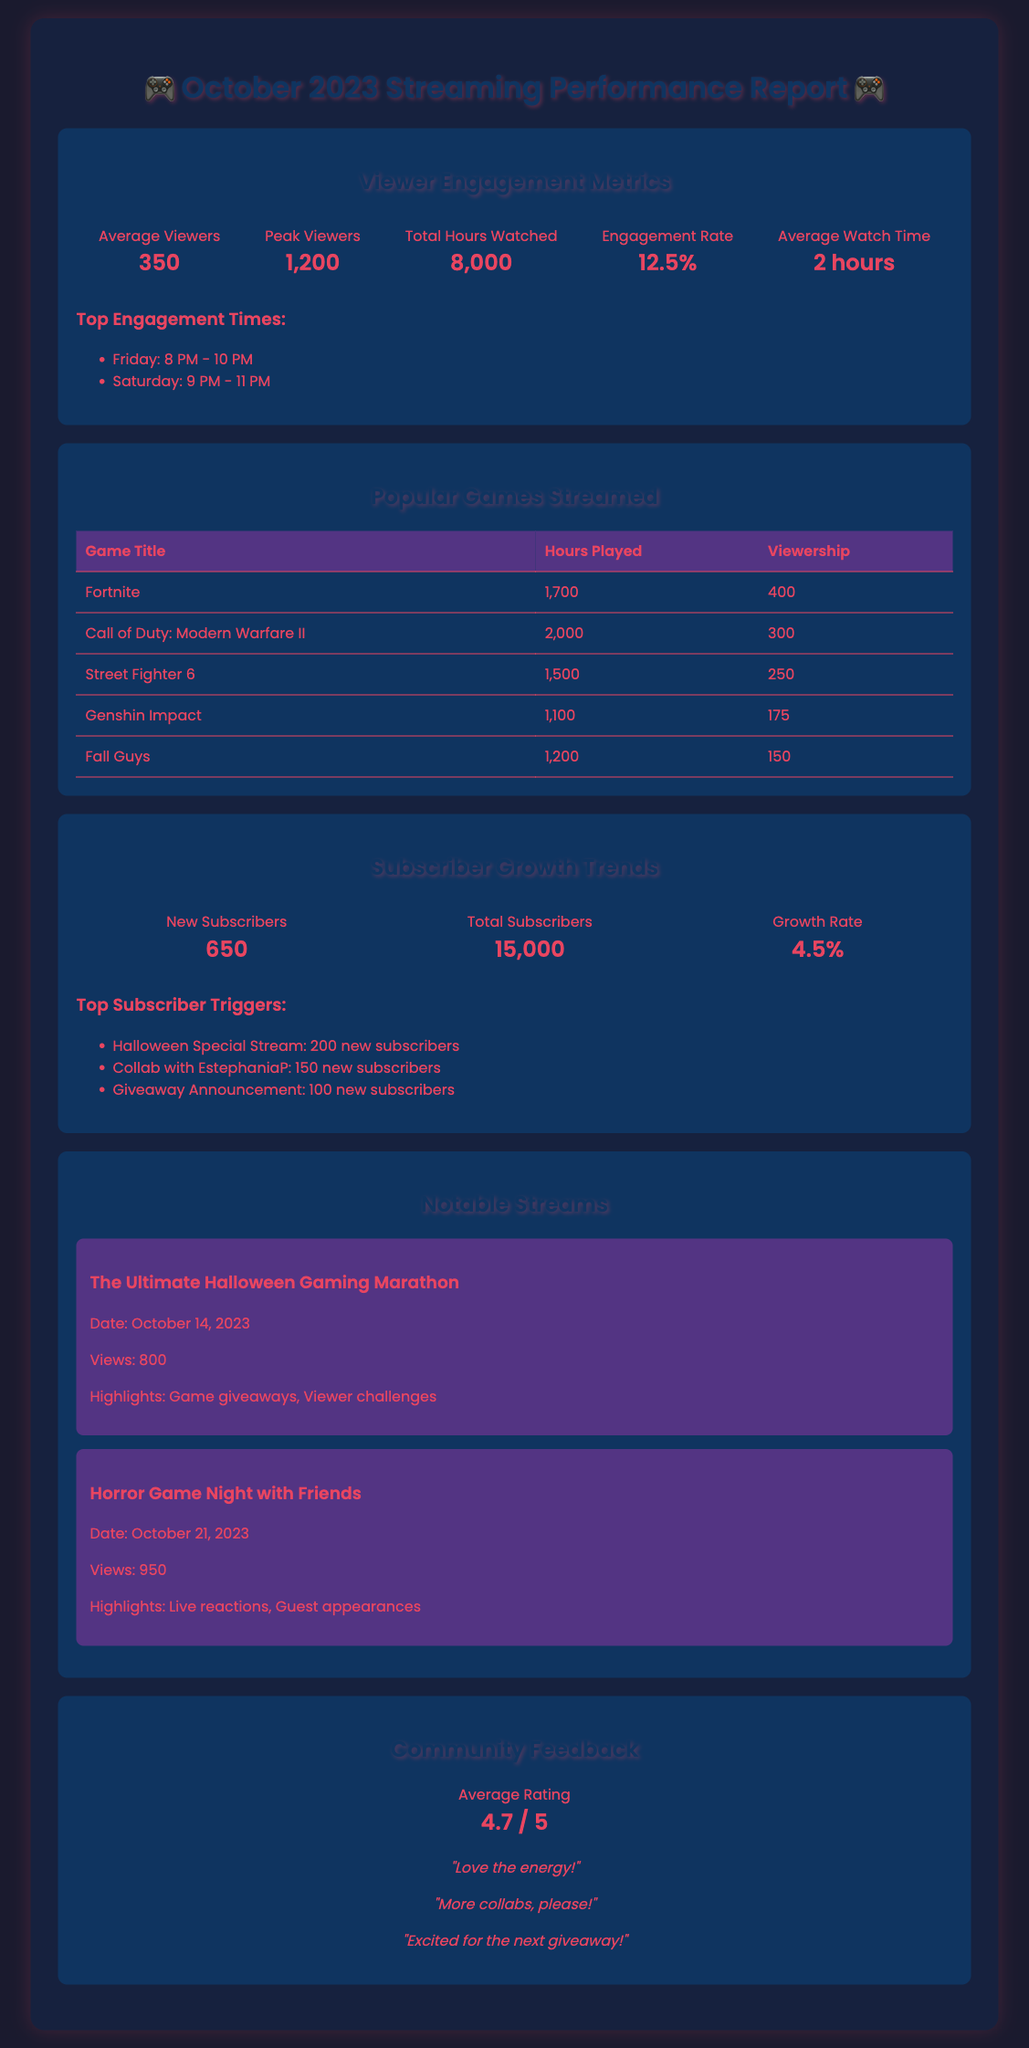What is the average number of viewers? The average number of viewers is listed under Viewer Engagement Metrics as 350.
Answer: 350 What was the peak viewership reported? The peak viewership is indicated as 1,200 in the Viewer Engagement Metrics section.
Answer: 1,200 Which game was played for the most hours? The game with the most hours played is Call of Duty: Modern Warfare II with 2,000 hours according to the Popular Games Streamed section.
Answer: Call of Duty: Modern Warfare II How many new subscribers were gained in October 2023? The number of new subscribers is detailed in the Subscriber Growth Trends section as 650.
Answer: 650 What is the average rating given by the community? The average rating is found in the Community Feedback section and is 4.7 out of 5.
Answer: 4.7 / 5 What were the top engagement times for streaming? The top engagement times listed are Friday from 8 PM to 10 PM and Saturday from 9 PM to 11 PM.
Answer: Friday: 8 PM - 10 PM, Saturday: 9 PM - 11 PM What is the growth rate of subscribers? The growth rate is mentioned in the Subscriber Growth Trends as 4.5%.
Answer: 4.5% When was the Ultimate Halloween Gaming Marathon streamed? The date of The Ultimate Halloween Gaming Marathon is noted as October 14, 2023 in the Notable Streams section.
Answer: October 14, 2023 What app triggered the most subscriber growth? The Halloween Special Stream triggered the most subscriber growth, adding 200 new subscribers according to the Subscriber Growth Trends.
Answer: Halloween Special Stream 